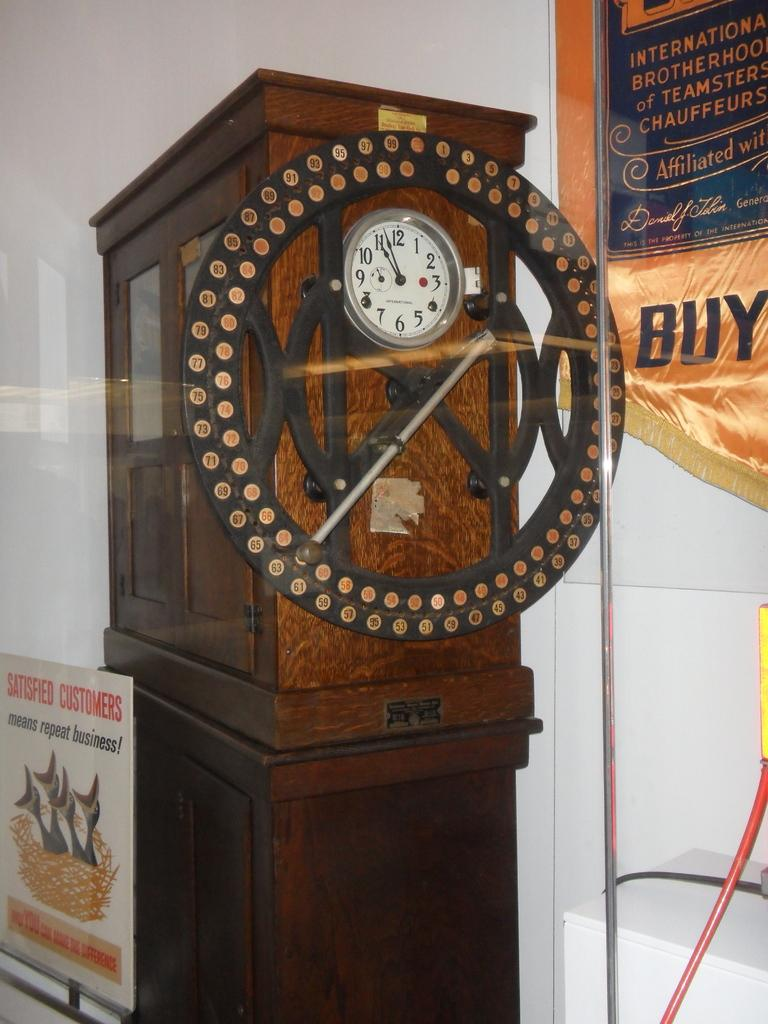<image>
Provide a brief description of the given image. A large wall clock is hanging on the side of a hutch with a poster standing in front of the hutch that says satisfied customers means repeat business. 